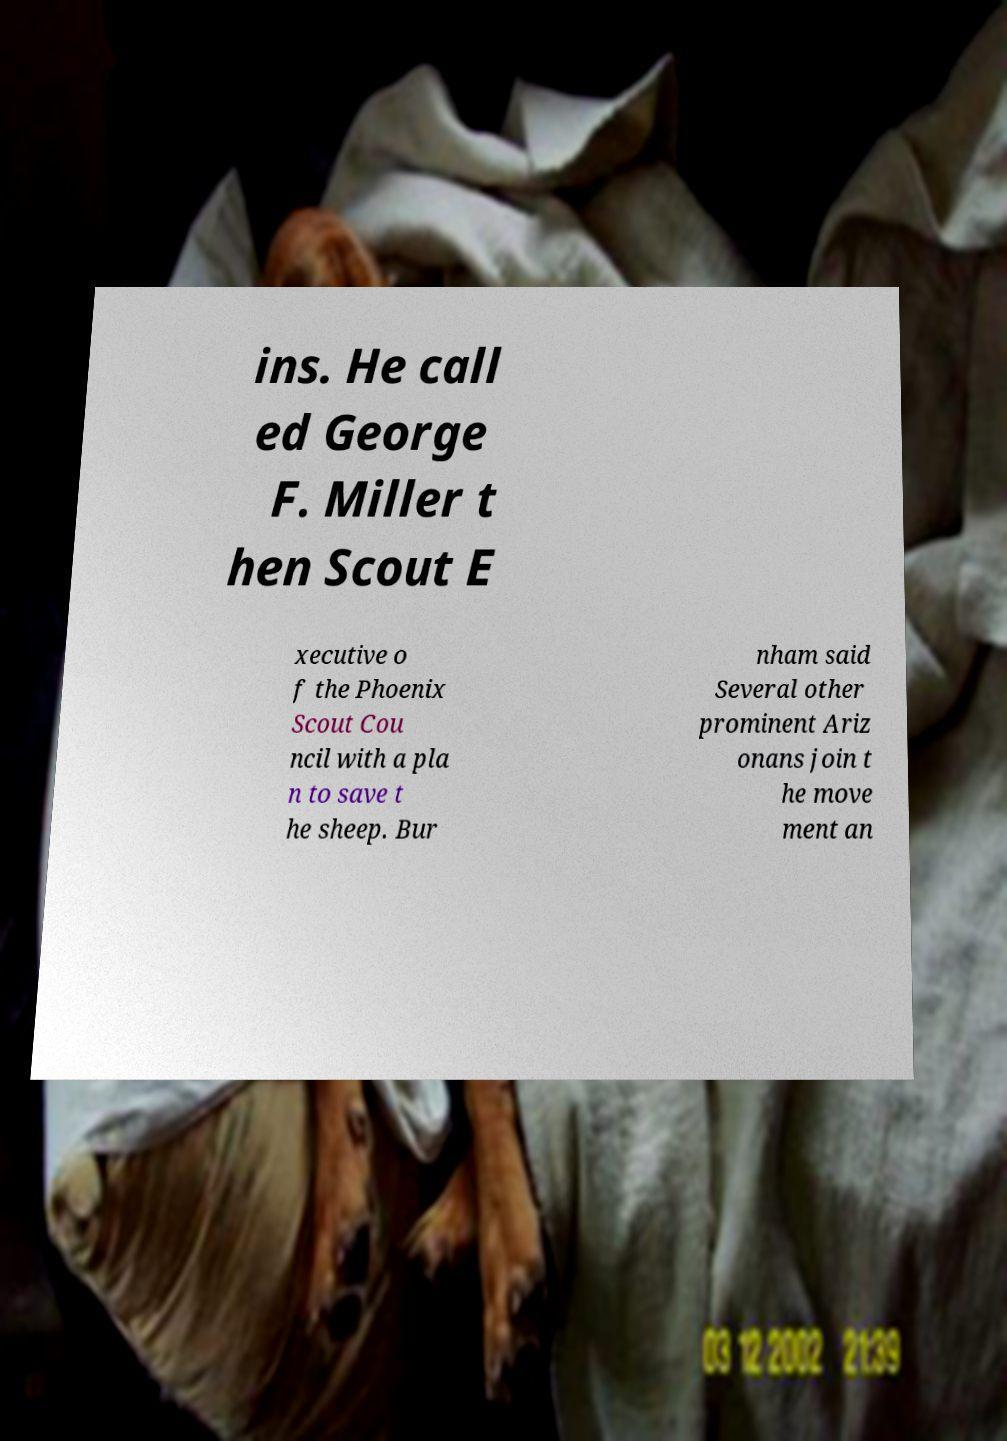Can you read and provide the text displayed in the image?This photo seems to have some interesting text. Can you extract and type it out for me? ins. He call ed George F. Miller t hen Scout E xecutive o f the Phoenix Scout Cou ncil with a pla n to save t he sheep. Bur nham said Several other prominent Ariz onans join t he move ment an 